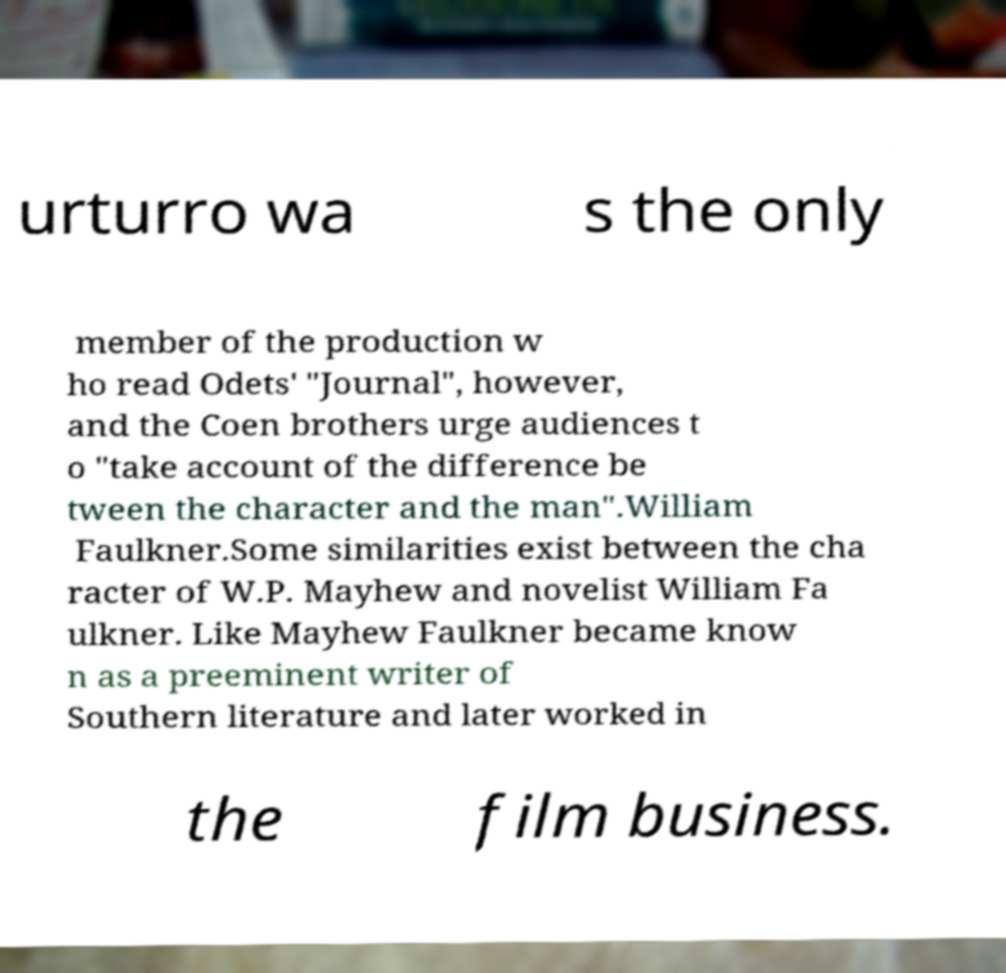Please read and relay the text visible in this image. What does it say? urturro wa s the only member of the production w ho read Odets' "Journal", however, and the Coen brothers urge audiences t o "take account of the difference be tween the character and the man".William Faulkner.Some similarities exist between the cha racter of W.P. Mayhew and novelist William Fa ulkner. Like Mayhew Faulkner became know n as a preeminent writer of Southern literature and later worked in the film business. 